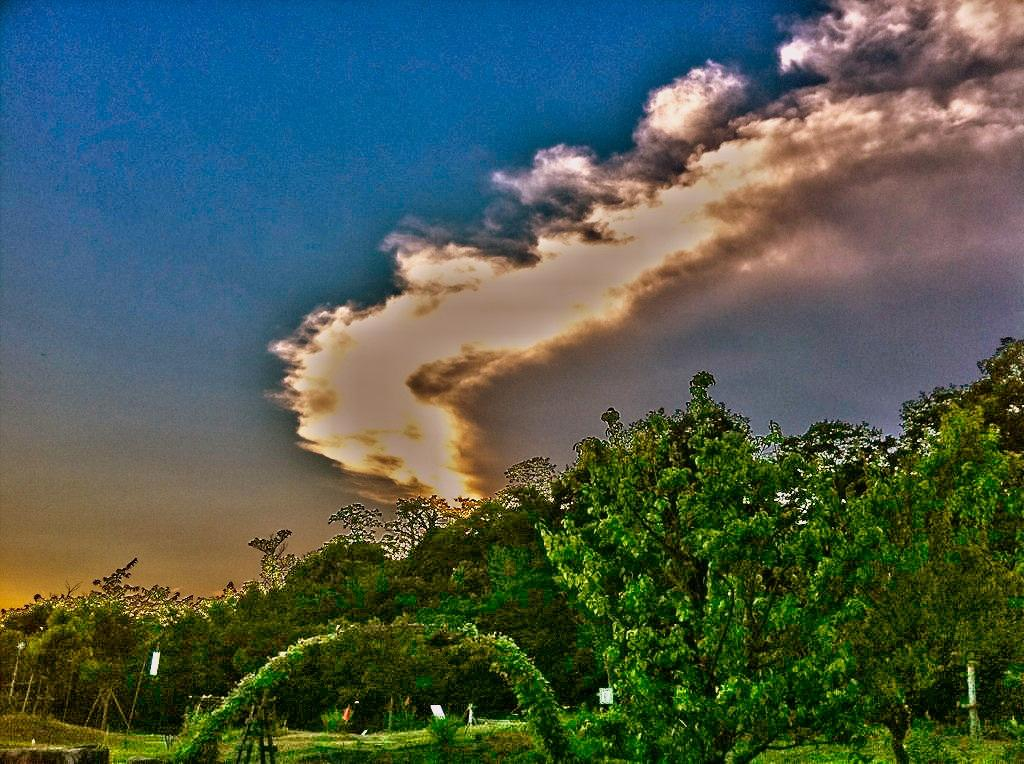What can be seen at the bottom of the image? There are trees, boards, and other unspecified things at the bottom of the image. What is visible at the top of the image? The sky is visible at the top of the image. How would you describe the sky in the image? The sky is cloudy in the image. What type of acoustics can be heard in the garden in the image? There is no garden present in the image, and therefore no acoustics can be heard. Can you describe the brush used to paint the trees in the image? There is no brush or painting involved in the image; it is a photograph or illustration of real trees. 